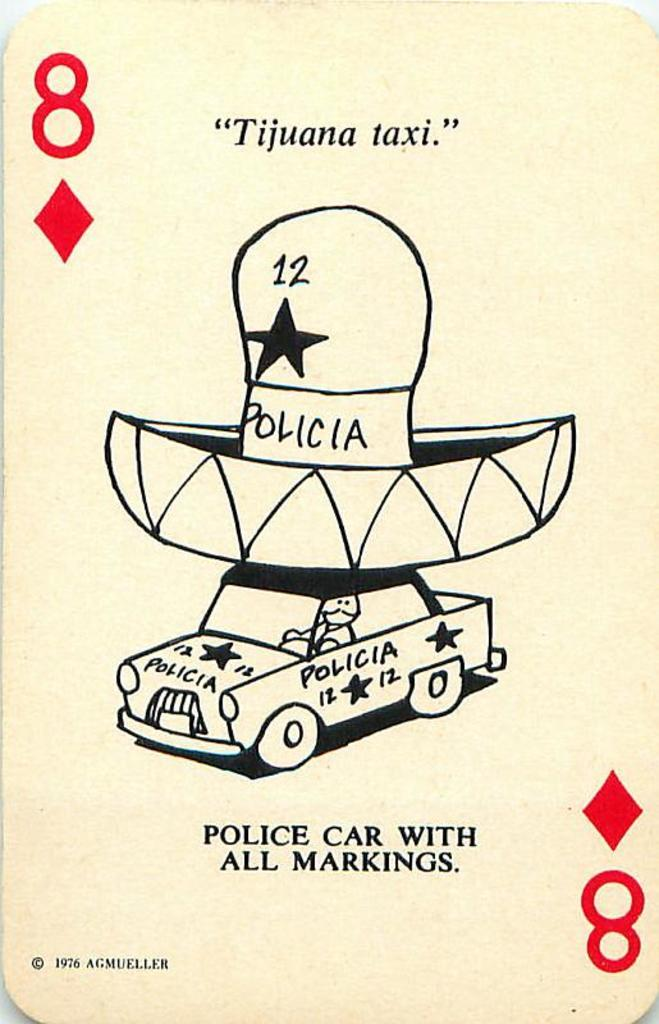What is featured on the poster in the image? The poster contains a car. Are there any other elements on the poster besides the car? Yes, there is text written on the poster. What type of rose can be seen in the image? There is no rose present in the image. What kind of humor is depicted in the image? There is no humor depicted in the image, as it only features a poster with a car and text. 